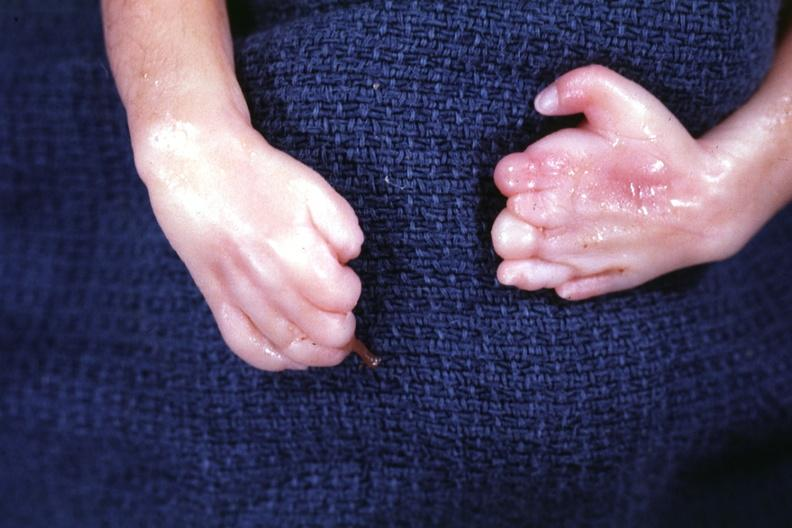s dysplastic present?
Answer the question using a single word or phrase. Dysplastic 